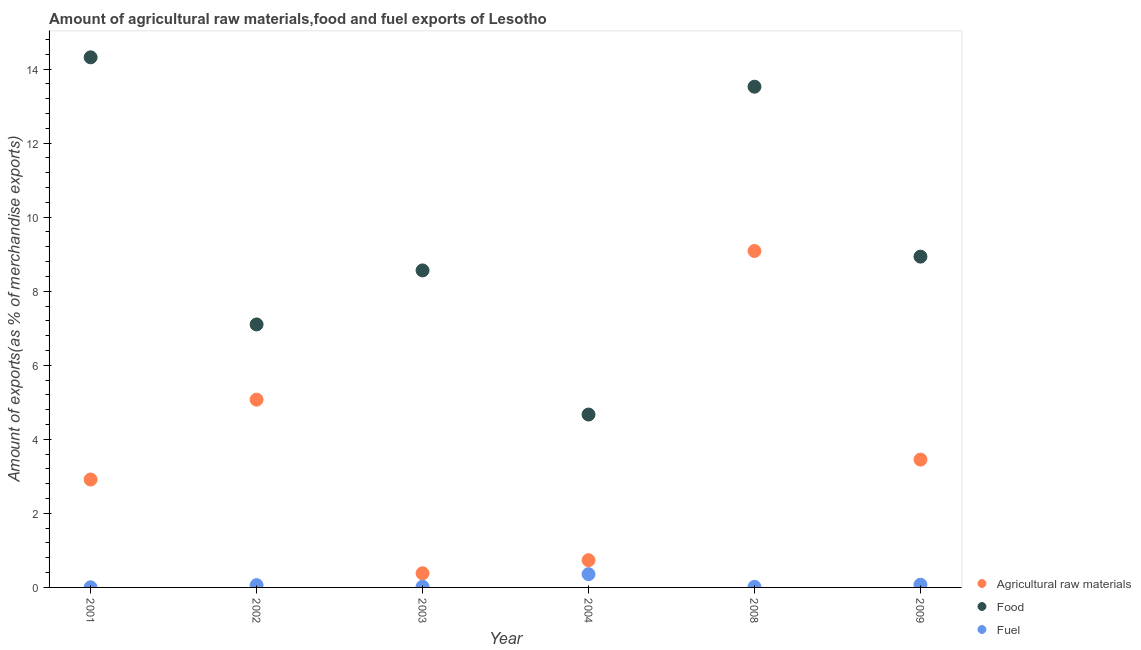What is the percentage of fuel exports in 2008?
Keep it short and to the point. 0.02. Across all years, what is the maximum percentage of food exports?
Your answer should be compact. 14.32. Across all years, what is the minimum percentage of raw materials exports?
Your answer should be compact. 0.38. What is the total percentage of fuel exports in the graph?
Offer a very short reply. 0.53. What is the difference between the percentage of fuel exports in 2001 and that in 2009?
Your response must be concise. -0.07. What is the difference between the percentage of food exports in 2002 and the percentage of fuel exports in 2008?
Provide a short and direct response. 7.09. What is the average percentage of food exports per year?
Your answer should be very brief. 9.52. In the year 2003, what is the difference between the percentage of raw materials exports and percentage of fuel exports?
Give a very brief answer. 0.36. What is the ratio of the percentage of raw materials exports in 2002 to that in 2003?
Your answer should be very brief. 13.26. What is the difference between the highest and the second highest percentage of raw materials exports?
Your response must be concise. 4.02. What is the difference between the highest and the lowest percentage of raw materials exports?
Ensure brevity in your answer.  8.7. In how many years, is the percentage of fuel exports greater than the average percentage of fuel exports taken over all years?
Provide a short and direct response. 1. Is it the case that in every year, the sum of the percentage of raw materials exports and percentage of food exports is greater than the percentage of fuel exports?
Give a very brief answer. Yes. Does the percentage of food exports monotonically increase over the years?
Keep it short and to the point. No. How many dotlines are there?
Keep it short and to the point. 3. Are the values on the major ticks of Y-axis written in scientific E-notation?
Your response must be concise. No. Does the graph contain grids?
Make the answer very short. No. Where does the legend appear in the graph?
Your response must be concise. Bottom right. What is the title of the graph?
Your answer should be compact. Amount of agricultural raw materials,food and fuel exports of Lesotho. Does "Travel services" appear as one of the legend labels in the graph?
Provide a succinct answer. No. What is the label or title of the X-axis?
Ensure brevity in your answer.  Year. What is the label or title of the Y-axis?
Ensure brevity in your answer.  Amount of exports(as % of merchandise exports). What is the Amount of exports(as % of merchandise exports) of Agricultural raw materials in 2001?
Your response must be concise. 2.91. What is the Amount of exports(as % of merchandise exports) of Food in 2001?
Your answer should be compact. 14.32. What is the Amount of exports(as % of merchandise exports) of Fuel in 2001?
Your answer should be compact. 0. What is the Amount of exports(as % of merchandise exports) of Agricultural raw materials in 2002?
Provide a succinct answer. 5.07. What is the Amount of exports(as % of merchandise exports) of Food in 2002?
Your answer should be compact. 7.1. What is the Amount of exports(as % of merchandise exports) of Fuel in 2002?
Your response must be concise. 0.06. What is the Amount of exports(as % of merchandise exports) of Agricultural raw materials in 2003?
Make the answer very short. 0.38. What is the Amount of exports(as % of merchandise exports) of Food in 2003?
Your answer should be very brief. 8.56. What is the Amount of exports(as % of merchandise exports) of Fuel in 2003?
Your answer should be compact. 0.02. What is the Amount of exports(as % of merchandise exports) in Agricultural raw materials in 2004?
Offer a terse response. 0.74. What is the Amount of exports(as % of merchandise exports) of Food in 2004?
Provide a succinct answer. 4.67. What is the Amount of exports(as % of merchandise exports) of Fuel in 2004?
Your answer should be compact. 0.36. What is the Amount of exports(as % of merchandise exports) in Agricultural raw materials in 2008?
Keep it short and to the point. 9.09. What is the Amount of exports(as % of merchandise exports) of Food in 2008?
Your response must be concise. 13.52. What is the Amount of exports(as % of merchandise exports) of Fuel in 2008?
Your answer should be compact. 0.02. What is the Amount of exports(as % of merchandise exports) of Agricultural raw materials in 2009?
Provide a short and direct response. 3.45. What is the Amount of exports(as % of merchandise exports) of Food in 2009?
Provide a short and direct response. 8.93. What is the Amount of exports(as % of merchandise exports) in Fuel in 2009?
Give a very brief answer. 0.07. Across all years, what is the maximum Amount of exports(as % of merchandise exports) in Agricultural raw materials?
Keep it short and to the point. 9.09. Across all years, what is the maximum Amount of exports(as % of merchandise exports) of Food?
Provide a succinct answer. 14.32. Across all years, what is the maximum Amount of exports(as % of merchandise exports) in Fuel?
Make the answer very short. 0.36. Across all years, what is the minimum Amount of exports(as % of merchandise exports) in Agricultural raw materials?
Ensure brevity in your answer.  0.38. Across all years, what is the minimum Amount of exports(as % of merchandise exports) in Food?
Your response must be concise. 4.67. Across all years, what is the minimum Amount of exports(as % of merchandise exports) in Fuel?
Offer a terse response. 0. What is the total Amount of exports(as % of merchandise exports) of Agricultural raw materials in the graph?
Your answer should be very brief. 21.64. What is the total Amount of exports(as % of merchandise exports) of Food in the graph?
Give a very brief answer. 57.11. What is the total Amount of exports(as % of merchandise exports) in Fuel in the graph?
Keep it short and to the point. 0.53. What is the difference between the Amount of exports(as % of merchandise exports) in Agricultural raw materials in 2001 and that in 2002?
Ensure brevity in your answer.  -2.16. What is the difference between the Amount of exports(as % of merchandise exports) of Food in 2001 and that in 2002?
Give a very brief answer. 7.21. What is the difference between the Amount of exports(as % of merchandise exports) of Fuel in 2001 and that in 2002?
Provide a short and direct response. -0.06. What is the difference between the Amount of exports(as % of merchandise exports) in Agricultural raw materials in 2001 and that in 2003?
Your response must be concise. 2.53. What is the difference between the Amount of exports(as % of merchandise exports) of Food in 2001 and that in 2003?
Offer a terse response. 5.76. What is the difference between the Amount of exports(as % of merchandise exports) of Fuel in 2001 and that in 2003?
Your response must be concise. -0.02. What is the difference between the Amount of exports(as % of merchandise exports) in Agricultural raw materials in 2001 and that in 2004?
Offer a very short reply. 2.18. What is the difference between the Amount of exports(as % of merchandise exports) in Food in 2001 and that in 2004?
Make the answer very short. 9.65. What is the difference between the Amount of exports(as % of merchandise exports) of Fuel in 2001 and that in 2004?
Provide a short and direct response. -0.36. What is the difference between the Amount of exports(as % of merchandise exports) of Agricultural raw materials in 2001 and that in 2008?
Provide a succinct answer. -6.17. What is the difference between the Amount of exports(as % of merchandise exports) of Food in 2001 and that in 2008?
Give a very brief answer. 0.79. What is the difference between the Amount of exports(as % of merchandise exports) in Fuel in 2001 and that in 2008?
Give a very brief answer. -0.01. What is the difference between the Amount of exports(as % of merchandise exports) of Agricultural raw materials in 2001 and that in 2009?
Offer a terse response. -0.54. What is the difference between the Amount of exports(as % of merchandise exports) of Food in 2001 and that in 2009?
Provide a succinct answer. 5.38. What is the difference between the Amount of exports(as % of merchandise exports) of Fuel in 2001 and that in 2009?
Offer a very short reply. -0.07. What is the difference between the Amount of exports(as % of merchandise exports) in Agricultural raw materials in 2002 and that in 2003?
Keep it short and to the point. 4.69. What is the difference between the Amount of exports(as % of merchandise exports) in Food in 2002 and that in 2003?
Keep it short and to the point. -1.46. What is the difference between the Amount of exports(as % of merchandise exports) of Fuel in 2002 and that in 2003?
Ensure brevity in your answer.  0.04. What is the difference between the Amount of exports(as % of merchandise exports) of Agricultural raw materials in 2002 and that in 2004?
Ensure brevity in your answer.  4.34. What is the difference between the Amount of exports(as % of merchandise exports) of Food in 2002 and that in 2004?
Provide a succinct answer. 2.43. What is the difference between the Amount of exports(as % of merchandise exports) in Fuel in 2002 and that in 2004?
Your response must be concise. -0.3. What is the difference between the Amount of exports(as % of merchandise exports) of Agricultural raw materials in 2002 and that in 2008?
Ensure brevity in your answer.  -4.02. What is the difference between the Amount of exports(as % of merchandise exports) in Food in 2002 and that in 2008?
Ensure brevity in your answer.  -6.42. What is the difference between the Amount of exports(as % of merchandise exports) of Fuel in 2002 and that in 2008?
Offer a very short reply. 0.05. What is the difference between the Amount of exports(as % of merchandise exports) of Agricultural raw materials in 2002 and that in 2009?
Give a very brief answer. 1.62. What is the difference between the Amount of exports(as % of merchandise exports) in Food in 2002 and that in 2009?
Give a very brief answer. -1.83. What is the difference between the Amount of exports(as % of merchandise exports) in Fuel in 2002 and that in 2009?
Offer a very short reply. -0.01. What is the difference between the Amount of exports(as % of merchandise exports) in Agricultural raw materials in 2003 and that in 2004?
Give a very brief answer. -0.35. What is the difference between the Amount of exports(as % of merchandise exports) in Food in 2003 and that in 2004?
Provide a short and direct response. 3.89. What is the difference between the Amount of exports(as % of merchandise exports) in Fuel in 2003 and that in 2004?
Give a very brief answer. -0.34. What is the difference between the Amount of exports(as % of merchandise exports) in Agricultural raw materials in 2003 and that in 2008?
Your response must be concise. -8.7. What is the difference between the Amount of exports(as % of merchandise exports) in Food in 2003 and that in 2008?
Your response must be concise. -4.96. What is the difference between the Amount of exports(as % of merchandise exports) of Fuel in 2003 and that in 2008?
Your answer should be very brief. 0. What is the difference between the Amount of exports(as % of merchandise exports) of Agricultural raw materials in 2003 and that in 2009?
Provide a short and direct response. -3.07. What is the difference between the Amount of exports(as % of merchandise exports) of Food in 2003 and that in 2009?
Your answer should be compact. -0.37. What is the difference between the Amount of exports(as % of merchandise exports) in Fuel in 2003 and that in 2009?
Keep it short and to the point. -0.05. What is the difference between the Amount of exports(as % of merchandise exports) in Agricultural raw materials in 2004 and that in 2008?
Offer a very short reply. -8.35. What is the difference between the Amount of exports(as % of merchandise exports) in Food in 2004 and that in 2008?
Provide a succinct answer. -8.85. What is the difference between the Amount of exports(as % of merchandise exports) of Fuel in 2004 and that in 2008?
Your response must be concise. 0.34. What is the difference between the Amount of exports(as % of merchandise exports) of Agricultural raw materials in 2004 and that in 2009?
Provide a succinct answer. -2.72. What is the difference between the Amount of exports(as % of merchandise exports) in Food in 2004 and that in 2009?
Provide a short and direct response. -4.27. What is the difference between the Amount of exports(as % of merchandise exports) of Fuel in 2004 and that in 2009?
Provide a short and direct response. 0.29. What is the difference between the Amount of exports(as % of merchandise exports) in Agricultural raw materials in 2008 and that in 2009?
Provide a short and direct response. 5.63. What is the difference between the Amount of exports(as % of merchandise exports) in Food in 2008 and that in 2009?
Provide a short and direct response. 4.59. What is the difference between the Amount of exports(as % of merchandise exports) of Fuel in 2008 and that in 2009?
Your answer should be compact. -0.06. What is the difference between the Amount of exports(as % of merchandise exports) of Agricultural raw materials in 2001 and the Amount of exports(as % of merchandise exports) of Food in 2002?
Keep it short and to the point. -4.19. What is the difference between the Amount of exports(as % of merchandise exports) of Agricultural raw materials in 2001 and the Amount of exports(as % of merchandise exports) of Fuel in 2002?
Provide a succinct answer. 2.85. What is the difference between the Amount of exports(as % of merchandise exports) in Food in 2001 and the Amount of exports(as % of merchandise exports) in Fuel in 2002?
Your answer should be compact. 14.26. What is the difference between the Amount of exports(as % of merchandise exports) in Agricultural raw materials in 2001 and the Amount of exports(as % of merchandise exports) in Food in 2003?
Make the answer very short. -5.65. What is the difference between the Amount of exports(as % of merchandise exports) of Agricultural raw materials in 2001 and the Amount of exports(as % of merchandise exports) of Fuel in 2003?
Provide a succinct answer. 2.9. What is the difference between the Amount of exports(as % of merchandise exports) of Food in 2001 and the Amount of exports(as % of merchandise exports) of Fuel in 2003?
Provide a short and direct response. 14.3. What is the difference between the Amount of exports(as % of merchandise exports) of Agricultural raw materials in 2001 and the Amount of exports(as % of merchandise exports) of Food in 2004?
Give a very brief answer. -1.76. What is the difference between the Amount of exports(as % of merchandise exports) of Agricultural raw materials in 2001 and the Amount of exports(as % of merchandise exports) of Fuel in 2004?
Provide a short and direct response. 2.56. What is the difference between the Amount of exports(as % of merchandise exports) of Food in 2001 and the Amount of exports(as % of merchandise exports) of Fuel in 2004?
Give a very brief answer. 13.96. What is the difference between the Amount of exports(as % of merchandise exports) in Agricultural raw materials in 2001 and the Amount of exports(as % of merchandise exports) in Food in 2008?
Make the answer very short. -10.61. What is the difference between the Amount of exports(as % of merchandise exports) of Agricultural raw materials in 2001 and the Amount of exports(as % of merchandise exports) of Fuel in 2008?
Keep it short and to the point. 2.9. What is the difference between the Amount of exports(as % of merchandise exports) in Food in 2001 and the Amount of exports(as % of merchandise exports) in Fuel in 2008?
Provide a succinct answer. 14.3. What is the difference between the Amount of exports(as % of merchandise exports) in Agricultural raw materials in 2001 and the Amount of exports(as % of merchandise exports) in Food in 2009?
Offer a terse response. -6.02. What is the difference between the Amount of exports(as % of merchandise exports) in Agricultural raw materials in 2001 and the Amount of exports(as % of merchandise exports) in Fuel in 2009?
Offer a very short reply. 2.84. What is the difference between the Amount of exports(as % of merchandise exports) in Food in 2001 and the Amount of exports(as % of merchandise exports) in Fuel in 2009?
Provide a short and direct response. 14.25. What is the difference between the Amount of exports(as % of merchandise exports) of Agricultural raw materials in 2002 and the Amount of exports(as % of merchandise exports) of Food in 2003?
Offer a terse response. -3.49. What is the difference between the Amount of exports(as % of merchandise exports) of Agricultural raw materials in 2002 and the Amount of exports(as % of merchandise exports) of Fuel in 2003?
Offer a very short reply. 5.05. What is the difference between the Amount of exports(as % of merchandise exports) of Food in 2002 and the Amount of exports(as % of merchandise exports) of Fuel in 2003?
Keep it short and to the point. 7.08. What is the difference between the Amount of exports(as % of merchandise exports) in Agricultural raw materials in 2002 and the Amount of exports(as % of merchandise exports) in Food in 2004?
Provide a succinct answer. 0.4. What is the difference between the Amount of exports(as % of merchandise exports) of Agricultural raw materials in 2002 and the Amount of exports(as % of merchandise exports) of Fuel in 2004?
Offer a terse response. 4.71. What is the difference between the Amount of exports(as % of merchandise exports) in Food in 2002 and the Amount of exports(as % of merchandise exports) in Fuel in 2004?
Your answer should be compact. 6.74. What is the difference between the Amount of exports(as % of merchandise exports) of Agricultural raw materials in 2002 and the Amount of exports(as % of merchandise exports) of Food in 2008?
Make the answer very short. -8.45. What is the difference between the Amount of exports(as % of merchandise exports) of Agricultural raw materials in 2002 and the Amount of exports(as % of merchandise exports) of Fuel in 2008?
Give a very brief answer. 5.06. What is the difference between the Amount of exports(as % of merchandise exports) of Food in 2002 and the Amount of exports(as % of merchandise exports) of Fuel in 2008?
Keep it short and to the point. 7.09. What is the difference between the Amount of exports(as % of merchandise exports) in Agricultural raw materials in 2002 and the Amount of exports(as % of merchandise exports) in Food in 2009?
Keep it short and to the point. -3.86. What is the difference between the Amount of exports(as % of merchandise exports) of Agricultural raw materials in 2002 and the Amount of exports(as % of merchandise exports) of Fuel in 2009?
Provide a short and direct response. 5. What is the difference between the Amount of exports(as % of merchandise exports) of Food in 2002 and the Amount of exports(as % of merchandise exports) of Fuel in 2009?
Your answer should be compact. 7.03. What is the difference between the Amount of exports(as % of merchandise exports) of Agricultural raw materials in 2003 and the Amount of exports(as % of merchandise exports) of Food in 2004?
Ensure brevity in your answer.  -4.29. What is the difference between the Amount of exports(as % of merchandise exports) in Agricultural raw materials in 2003 and the Amount of exports(as % of merchandise exports) in Fuel in 2004?
Your answer should be very brief. 0.02. What is the difference between the Amount of exports(as % of merchandise exports) of Food in 2003 and the Amount of exports(as % of merchandise exports) of Fuel in 2004?
Your answer should be very brief. 8.2. What is the difference between the Amount of exports(as % of merchandise exports) of Agricultural raw materials in 2003 and the Amount of exports(as % of merchandise exports) of Food in 2008?
Offer a very short reply. -13.14. What is the difference between the Amount of exports(as % of merchandise exports) of Agricultural raw materials in 2003 and the Amount of exports(as % of merchandise exports) of Fuel in 2008?
Offer a terse response. 0.37. What is the difference between the Amount of exports(as % of merchandise exports) of Food in 2003 and the Amount of exports(as % of merchandise exports) of Fuel in 2008?
Provide a succinct answer. 8.55. What is the difference between the Amount of exports(as % of merchandise exports) of Agricultural raw materials in 2003 and the Amount of exports(as % of merchandise exports) of Food in 2009?
Give a very brief answer. -8.55. What is the difference between the Amount of exports(as % of merchandise exports) in Agricultural raw materials in 2003 and the Amount of exports(as % of merchandise exports) in Fuel in 2009?
Your answer should be compact. 0.31. What is the difference between the Amount of exports(as % of merchandise exports) of Food in 2003 and the Amount of exports(as % of merchandise exports) of Fuel in 2009?
Provide a short and direct response. 8.49. What is the difference between the Amount of exports(as % of merchandise exports) in Agricultural raw materials in 2004 and the Amount of exports(as % of merchandise exports) in Food in 2008?
Offer a very short reply. -12.79. What is the difference between the Amount of exports(as % of merchandise exports) in Agricultural raw materials in 2004 and the Amount of exports(as % of merchandise exports) in Fuel in 2008?
Offer a very short reply. 0.72. What is the difference between the Amount of exports(as % of merchandise exports) in Food in 2004 and the Amount of exports(as % of merchandise exports) in Fuel in 2008?
Your response must be concise. 4.65. What is the difference between the Amount of exports(as % of merchandise exports) of Agricultural raw materials in 2004 and the Amount of exports(as % of merchandise exports) of Food in 2009?
Make the answer very short. -8.2. What is the difference between the Amount of exports(as % of merchandise exports) in Agricultural raw materials in 2004 and the Amount of exports(as % of merchandise exports) in Fuel in 2009?
Make the answer very short. 0.66. What is the difference between the Amount of exports(as % of merchandise exports) of Food in 2004 and the Amount of exports(as % of merchandise exports) of Fuel in 2009?
Provide a short and direct response. 4.6. What is the difference between the Amount of exports(as % of merchandise exports) of Agricultural raw materials in 2008 and the Amount of exports(as % of merchandise exports) of Food in 2009?
Keep it short and to the point. 0.15. What is the difference between the Amount of exports(as % of merchandise exports) of Agricultural raw materials in 2008 and the Amount of exports(as % of merchandise exports) of Fuel in 2009?
Provide a succinct answer. 9.01. What is the difference between the Amount of exports(as % of merchandise exports) in Food in 2008 and the Amount of exports(as % of merchandise exports) in Fuel in 2009?
Make the answer very short. 13.45. What is the average Amount of exports(as % of merchandise exports) of Agricultural raw materials per year?
Provide a succinct answer. 3.61. What is the average Amount of exports(as % of merchandise exports) of Food per year?
Give a very brief answer. 9.52. What is the average Amount of exports(as % of merchandise exports) in Fuel per year?
Keep it short and to the point. 0.09. In the year 2001, what is the difference between the Amount of exports(as % of merchandise exports) in Agricultural raw materials and Amount of exports(as % of merchandise exports) in Food?
Offer a very short reply. -11.4. In the year 2001, what is the difference between the Amount of exports(as % of merchandise exports) in Agricultural raw materials and Amount of exports(as % of merchandise exports) in Fuel?
Give a very brief answer. 2.91. In the year 2001, what is the difference between the Amount of exports(as % of merchandise exports) in Food and Amount of exports(as % of merchandise exports) in Fuel?
Offer a terse response. 14.31. In the year 2002, what is the difference between the Amount of exports(as % of merchandise exports) of Agricultural raw materials and Amount of exports(as % of merchandise exports) of Food?
Make the answer very short. -2.03. In the year 2002, what is the difference between the Amount of exports(as % of merchandise exports) in Agricultural raw materials and Amount of exports(as % of merchandise exports) in Fuel?
Ensure brevity in your answer.  5.01. In the year 2002, what is the difference between the Amount of exports(as % of merchandise exports) of Food and Amount of exports(as % of merchandise exports) of Fuel?
Your answer should be very brief. 7.04. In the year 2003, what is the difference between the Amount of exports(as % of merchandise exports) in Agricultural raw materials and Amount of exports(as % of merchandise exports) in Food?
Provide a short and direct response. -8.18. In the year 2003, what is the difference between the Amount of exports(as % of merchandise exports) of Agricultural raw materials and Amount of exports(as % of merchandise exports) of Fuel?
Offer a terse response. 0.36. In the year 2003, what is the difference between the Amount of exports(as % of merchandise exports) of Food and Amount of exports(as % of merchandise exports) of Fuel?
Your answer should be very brief. 8.54. In the year 2004, what is the difference between the Amount of exports(as % of merchandise exports) of Agricultural raw materials and Amount of exports(as % of merchandise exports) of Food?
Give a very brief answer. -3.93. In the year 2004, what is the difference between the Amount of exports(as % of merchandise exports) in Agricultural raw materials and Amount of exports(as % of merchandise exports) in Fuel?
Provide a short and direct response. 0.38. In the year 2004, what is the difference between the Amount of exports(as % of merchandise exports) of Food and Amount of exports(as % of merchandise exports) of Fuel?
Give a very brief answer. 4.31. In the year 2008, what is the difference between the Amount of exports(as % of merchandise exports) in Agricultural raw materials and Amount of exports(as % of merchandise exports) in Food?
Your response must be concise. -4.44. In the year 2008, what is the difference between the Amount of exports(as % of merchandise exports) in Agricultural raw materials and Amount of exports(as % of merchandise exports) in Fuel?
Provide a short and direct response. 9.07. In the year 2008, what is the difference between the Amount of exports(as % of merchandise exports) of Food and Amount of exports(as % of merchandise exports) of Fuel?
Offer a terse response. 13.51. In the year 2009, what is the difference between the Amount of exports(as % of merchandise exports) of Agricultural raw materials and Amount of exports(as % of merchandise exports) of Food?
Make the answer very short. -5.48. In the year 2009, what is the difference between the Amount of exports(as % of merchandise exports) of Agricultural raw materials and Amount of exports(as % of merchandise exports) of Fuel?
Make the answer very short. 3.38. In the year 2009, what is the difference between the Amount of exports(as % of merchandise exports) of Food and Amount of exports(as % of merchandise exports) of Fuel?
Give a very brief answer. 8.86. What is the ratio of the Amount of exports(as % of merchandise exports) of Agricultural raw materials in 2001 to that in 2002?
Provide a succinct answer. 0.57. What is the ratio of the Amount of exports(as % of merchandise exports) in Food in 2001 to that in 2002?
Provide a succinct answer. 2.02. What is the ratio of the Amount of exports(as % of merchandise exports) in Fuel in 2001 to that in 2002?
Give a very brief answer. 0.05. What is the ratio of the Amount of exports(as % of merchandise exports) in Agricultural raw materials in 2001 to that in 2003?
Your response must be concise. 7.62. What is the ratio of the Amount of exports(as % of merchandise exports) of Food in 2001 to that in 2003?
Keep it short and to the point. 1.67. What is the ratio of the Amount of exports(as % of merchandise exports) in Fuel in 2001 to that in 2003?
Offer a very short reply. 0.18. What is the ratio of the Amount of exports(as % of merchandise exports) of Agricultural raw materials in 2001 to that in 2004?
Your response must be concise. 3.96. What is the ratio of the Amount of exports(as % of merchandise exports) in Food in 2001 to that in 2004?
Your answer should be compact. 3.07. What is the ratio of the Amount of exports(as % of merchandise exports) of Fuel in 2001 to that in 2004?
Provide a succinct answer. 0.01. What is the ratio of the Amount of exports(as % of merchandise exports) in Agricultural raw materials in 2001 to that in 2008?
Make the answer very short. 0.32. What is the ratio of the Amount of exports(as % of merchandise exports) of Food in 2001 to that in 2008?
Make the answer very short. 1.06. What is the ratio of the Amount of exports(as % of merchandise exports) in Fuel in 2001 to that in 2008?
Make the answer very short. 0.21. What is the ratio of the Amount of exports(as % of merchandise exports) in Agricultural raw materials in 2001 to that in 2009?
Your answer should be compact. 0.84. What is the ratio of the Amount of exports(as % of merchandise exports) in Food in 2001 to that in 2009?
Provide a short and direct response. 1.6. What is the ratio of the Amount of exports(as % of merchandise exports) in Fuel in 2001 to that in 2009?
Give a very brief answer. 0.05. What is the ratio of the Amount of exports(as % of merchandise exports) of Agricultural raw materials in 2002 to that in 2003?
Offer a terse response. 13.26. What is the ratio of the Amount of exports(as % of merchandise exports) in Food in 2002 to that in 2003?
Make the answer very short. 0.83. What is the ratio of the Amount of exports(as % of merchandise exports) in Fuel in 2002 to that in 2003?
Keep it short and to the point. 3.3. What is the ratio of the Amount of exports(as % of merchandise exports) in Agricultural raw materials in 2002 to that in 2004?
Provide a succinct answer. 6.89. What is the ratio of the Amount of exports(as % of merchandise exports) of Food in 2002 to that in 2004?
Your response must be concise. 1.52. What is the ratio of the Amount of exports(as % of merchandise exports) in Fuel in 2002 to that in 2004?
Ensure brevity in your answer.  0.17. What is the ratio of the Amount of exports(as % of merchandise exports) in Agricultural raw materials in 2002 to that in 2008?
Your response must be concise. 0.56. What is the ratio of the Amount of exports(as % of merchandise exports) in Food in 2002 to that in 2008?
Make the answer very short. 0.53. What is the ratio of the Amount of exports(as % of merchandise exports) in Fuel in 2002 to that in 2008?
Keep it short and to the point. 3.92. What is the ratio of the Amount of exports(as % of merchandise exports) in Agricultural raw materials in 2002 to that in 2009?
Your answer should be compact. 1.47. What is the ratio of the Amount of exports(as % of merchandise exports) of Food in 2002 to that in 2009?
Provide a succinct answer. 0.8. What is the ratio of the Amount of exports(as % of merchandise exports) in Fuel in 2002 to that in 2009?
Offer a terse response. 0.86. What is the ratio of the Amount of exports(as % of merchandise exports) in Agricultural raw materials in 2003 to that in 2004?
Provide a succinct answer. 0.52. What is the ratio of the Amount of exports(as % of merchandise exports) of Food in 2003 to that in 2004?
Offer a terse response. 1.83. What is the ratio of the Amount of exports(as % of merchandise exports) in Fuel in 2003 to that in 2004?
Ensure brevity in your answer.  0.05. What is the ratio of the Amount of exports(as % of merchandise exports) in Agricultural raw materials in 2003 to that in 2008?
Provide a short and direct response. 0.04. What is the ratio of the Amount of exports(as % of merchandise exports) of Food in 2003 to that in 2008?
Your response must be concise. 0.63. What is the ratio of the Amount of exports(as % of merchandise exports) of Fuel in 2003 to that in 2008?
Your answer should be very brief. 1.19. What is the ratio of the Amount of exports(as % of merchandise exports) of Agricultural raw materials in 2003 to that in 2009?
Your response must be concise. 0.11. What is the ratio of the Amount of exports(as % of merchandise exports) of Food in 2003 to that in 2009?
Offer a very short reply. 0.96. What is the ratio of the Amount of exports(as % of merchandise exports) of Fuel in 2003 to that in 2009?
Your answer should be compact. 0.26. What is the ratio of the Amount of exports(as % of merchandise exports) in Agricultural raw materials in 2004 to that in 2008?
Keep it short and to the point. 0.08. What is the ratio of the Amount of exports(as % of merchandise exports) in Food in 2004 to that in 2008?
Give a very brief answer. 0.35. What is the ratio of the Amount of exports(as % of merchandise exports) in Fuel in 2004 to that in 2008?
Your answer should be compact. 22.53. What is the ratio of the Amount of exports(as % of merchandise exports) in Agricultural raw materials in 2004 to that in 2009?
Provide a succinct answer. 0.21. What is the ratio of the Amount of exports(as % of merchandise exports) of Food in 2004 to that in 2009?
Provide a short and direct response. 0.52. What is the ratio of the Amount of exports(as % of merchandise exports) of Fuel in 2004 to that in 2009?
Your answer should be very brief. 4.95. What is the ratio of the Amount of exports(as % of merchandise exports) in Agricultural raw materials in 2008 to that in 2009?
Offer a terse response. 2.63. What is the ratio of the Amount of exports(as % of merchandise exports) in Food in 2008 to that in 2009?
Offer a very short reply. 1.51. What is the ratio of the Amount of exports(as % of merchandise exports) of Fuel in 2008 to that in 2009?
Ensure brevity in your answer.  0.22. What is the difference between the highest and the second highest Amount of exports(as % of merchandise exports) in Agricultural raw materials?
Offer a terse response. 4.02. What is the difference between the highest and the second highest Amount of exports(as % of merchandise exports) of Food?
Give a very brief answer. 0.79. What is the difference between the highest and the second highest Amount of exports(as % of merchandise exports) of Fuel?
Ensure brevity in your answer.  0.29. What is the difference between the highest and the lowest Amount of exports(as % of merchandise exports) in Agricultural raw materials?
Keep it short and to the point. 8.7. What is the difference between the highest and the lowest Amount of exports(as % of merchandise exports) of Food?
Offer a terse response. 9.65. What is the difference between the highest and the lowest Amount of exports(as % of merchandise exports) in Fuel?
Your answer should be compact. 0.36. 